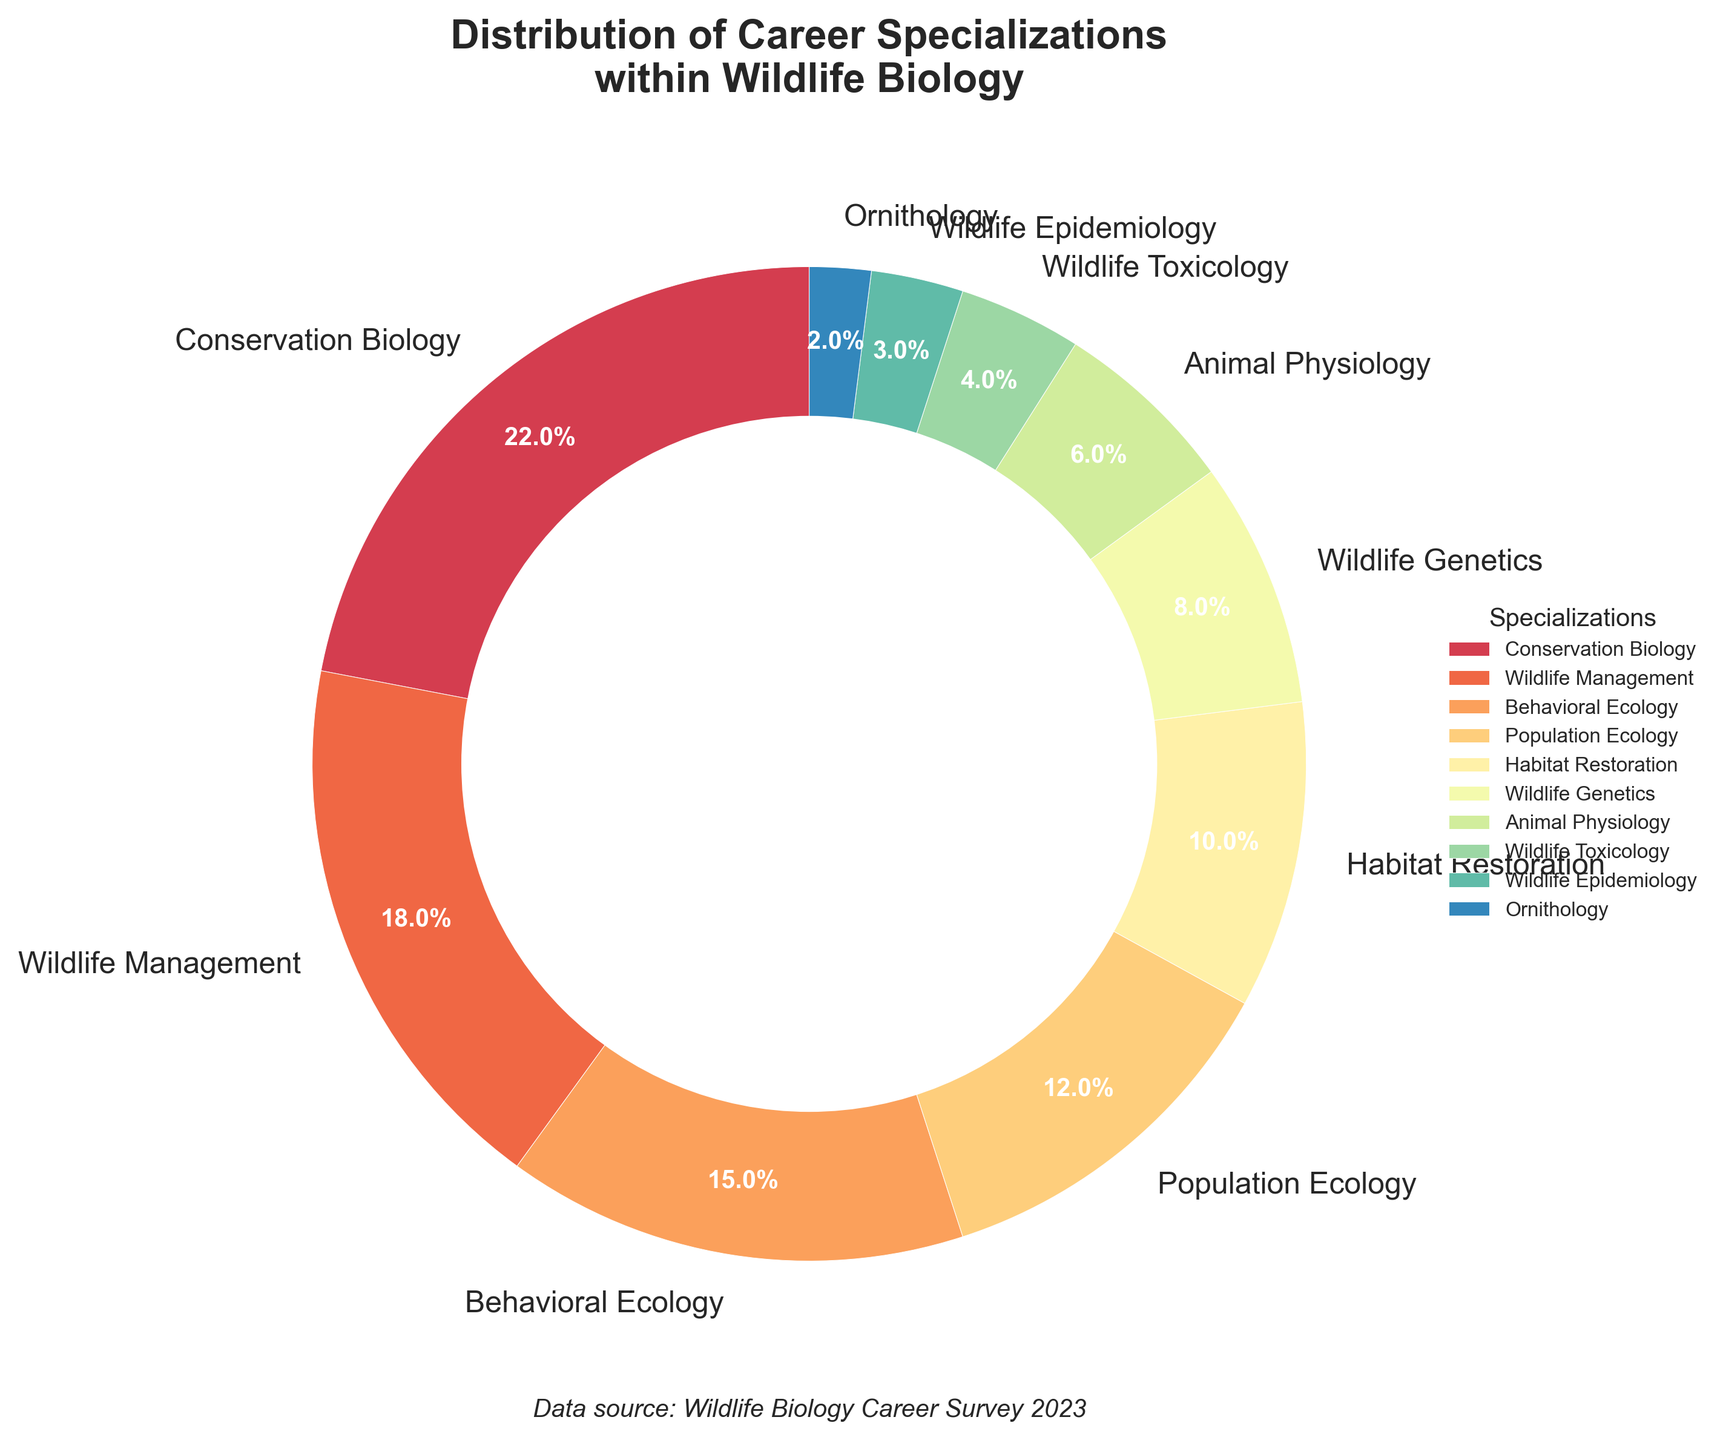What percentage of wildlife biologists specialize in Habitat Restoration? Looking at the pie chart, we can see the percentage allocated to Habitat Restoration. It is labeled as 10%.
Answer: 10% Which specialization has the smallest percentage in the pie chart? By examining the segments, the smallest one is clearly marked as Ornithology.
Answer: Ornithology How many percentage points larger is Conservation Biology compared to Wildlife Genetics? Conservation Biology has 22%, and Wildlife Genetics has 8%. The difference is 22% - 8% = 14%.
Answer: 14% What is the combined percentage of Wildlife Management and Behavioral Ecology specializations? Wildlife Management has 18%, and Behavioral Ecology has 15%. Adding them gives 18% + 15% = 33%.
Answer: 33% Which specialization ranks just below Animal Physiology in terms of percentage? Animal Physiology has 6%. The next larger segment is Wildlife Genetics with 8%.
Answer: Wildlife Genetics How does the percentage of those specializing in Wildlife Toxicology compare to those in Wildlife Epidemiology? Wildlife Toxicology has 4%, and Wildlife Epidemiology has 3%. Wildlife Toxicology is greater by 1%.
Answer: Wildlife Toxicology is greater by 1% What are the percentages for the three smallest specializations combined? The three smallest are Wildlife Epidemiology (3%), Ornithology (2%), and Wildlife Toxicology (4%). Combined, they are 3% + 2% + 4% = 9%.
Answer: 9% Is Behavioral Ecology more or less popular than Population Ecology, and by how much? Behavioral Ecology has 15%, while Population Ecology has 12%. Behavioral Ecology is more popular by 3%.
Answer: More by 3% What percentage of specializations fall within or below Animal Physiology’s percentage? The specializations at or below Animal Physiology’s 6% are Wildlife Physiology (6%), Wildlife Toxicology (4%), Wildlife Epidemiology (3%), and Ornithology (2%). Adding these gives 6% + 4% + 3% + 2% = 15%.
Answer: 15% If you were to group all specializations below 10% collectively, what would be the total percentage? The specializations below 10% are Wildlife Genetics (8%), Animal Physiology (6%), Wildlife Toxicology (4%), Wildlife Epidemiology (3%), and Ornithology (2%). Adding them gives 8% + 6% + 4% + 3% + 2% = 23%.
Answer: 23% 